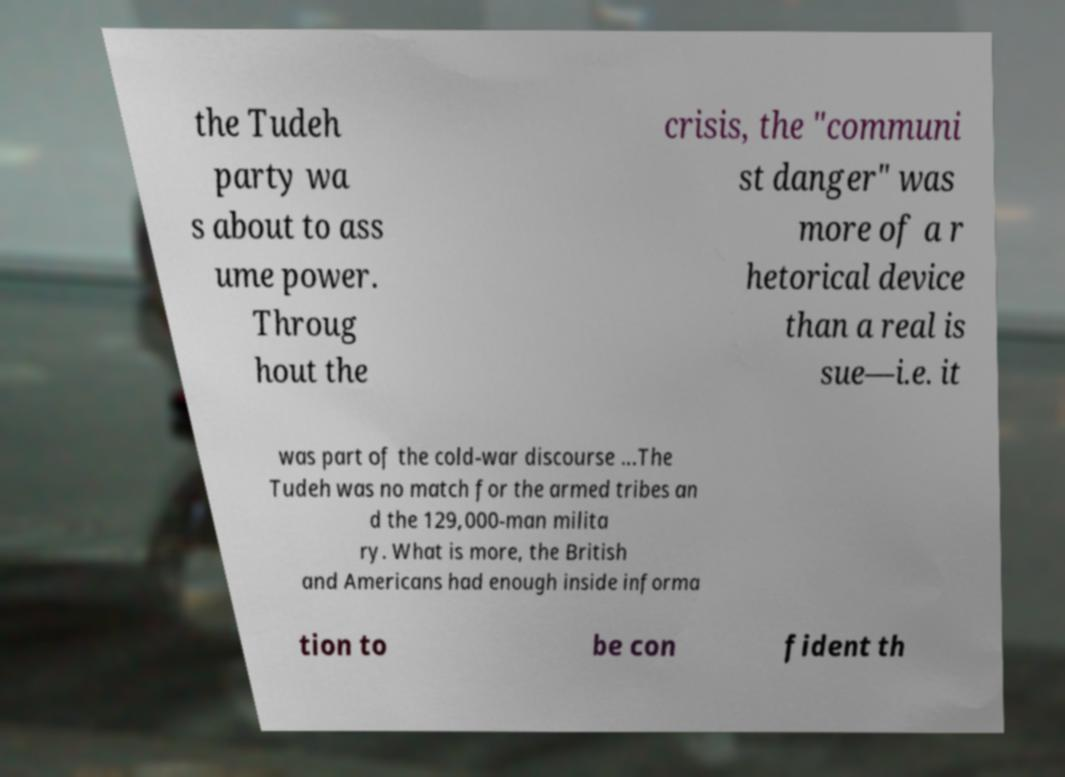Could you extract and type out the text from this image? the Tudeh party wa s about to ass ume power. Throug hout the crisis, the "communi st danger" was more of a r hetorical device than a real is sue—i.e. it was part of the cold-war discourse ...The Tudeh was no match for the armed tribes an d the 129,000-man milita ry. What is more, the British and Americans had enough inside informa tion to be con fident th 